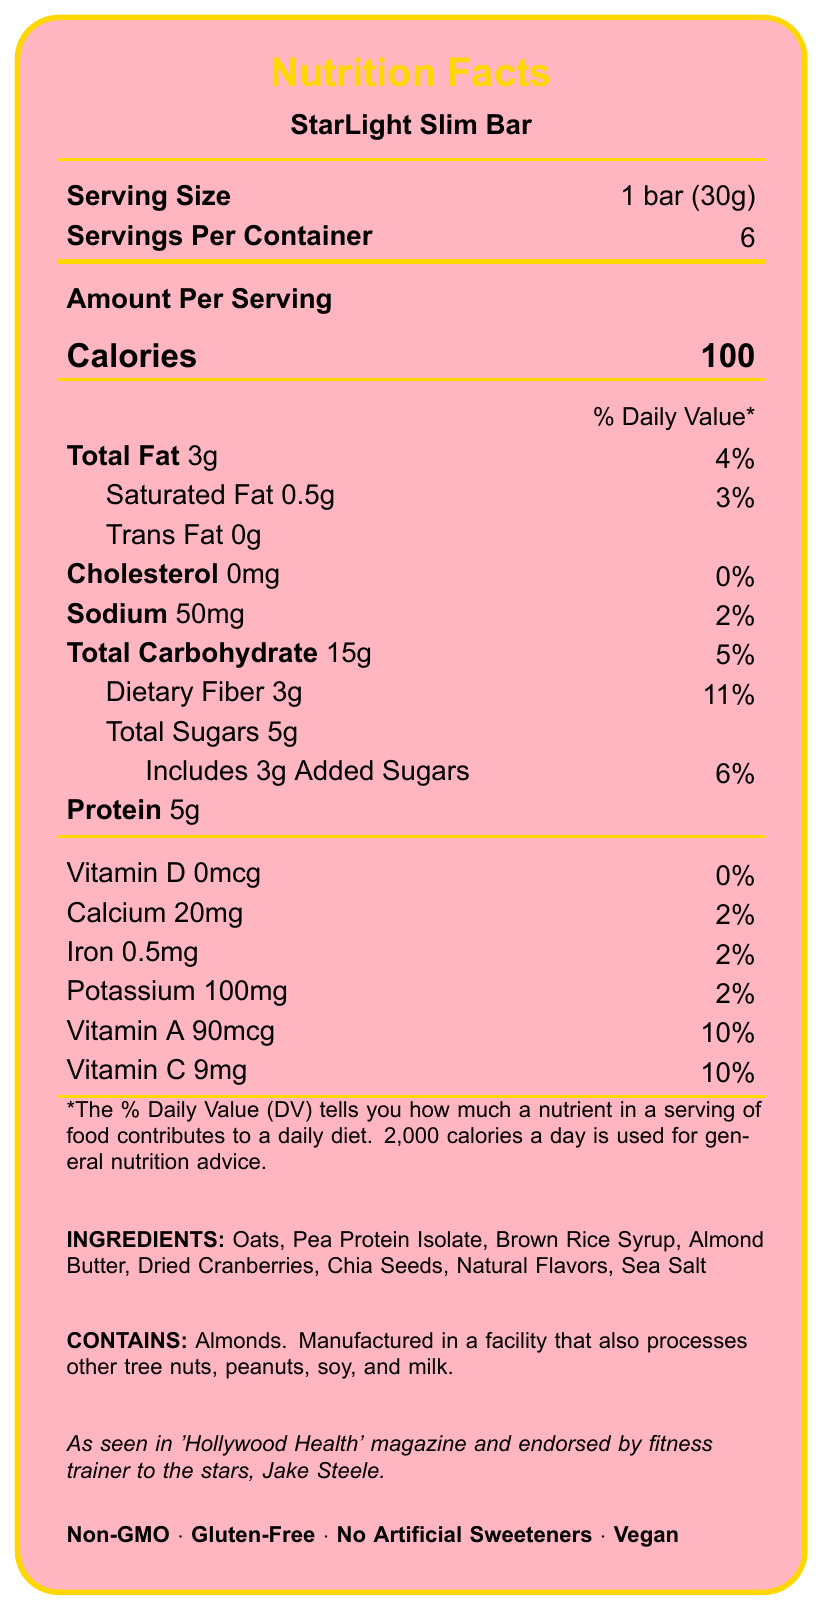what is the serving size? The serving size is listed at the top of the document, indicating it is 1 bar, which equals 30 grams.
Answer: 1 bar (30g) how many servings are in a container? The document states there are 6 servings per container, which is indicated near the top of the label.
Answer: 6 how many calories are in one serving? The number of calories per serving is 100, which is prominently displayed under the "Amount Per Serving" section.
Answer: 100 what is the total amount of fat per serving? The total fat content per serving is listed as 3 grams.
Answer: 3g what percentage of the daily value is the dietary fiber in one serving? The document states that dietary fiber makes up 11% of the daily value per serving.
Answer: 11% which of the following is not included in the ingredients? A. Oats B. Almond Butter C. Soy Protein D. Chia Seeds The listed ingredients include oats, almond butter, and chia seeds but not soy protein.
Answer: C how much sodium is in one serving? A. 20mg B. 50mg C. 100mg D. 200mg The sodium content per serving is listed as 50mg on the nutrition facts label.
Answer: B is the product Vegan? The label explicitly states that the product is Vegan.
Answer: Yes does the snack bar contain any Vitamin D? The Vitamin D amount is listed as 0mcg, which implies there is no Vitamin D in the snack bar.
Answer: No summarize the main features of this product This summary highlights the key nutritional features and marketing aspects of the product as displayed in the document.
Answer: StarLight Slim Bar is a low-calorie snack bar with 100 calories per serving. It contains 3 grams of total fat, 15 grams of total carbohydrates, 5 grams of protein, and various other nutrients. The bar is Non-GMO, Gluten-Free, contains no artificial sweeteners, and is suitable for a Vegan diet. It is endorsed by a celebrity trainer and aims to help maintain a camera-ready figure. It also includes allergen information regarding almonds. what is the exact amount of Vitamin A provided per serving of the bar? The document indicates that each serving provides 90 micrograms of Vitamin A.
Answer: 90mcg how much protein is in one bar? The protein content per serving, indicated on the label, is 5 grams.
Answer: 5g what does the "Tinseltown Nutrition Co." do? The document mentions "Tinseltown Nutrition Co." as the distributor, but it does not provide details about their specific activities or roles.
Answer: Not enough information are there any artificial sweeteners in this snack bar? The document states that the product contains "No Artificial Sweeteners."
Answer: No how much sugar has been added to each serving? The document specifies that there are 3 grams of added sugars per serving.
Answer: 3g 